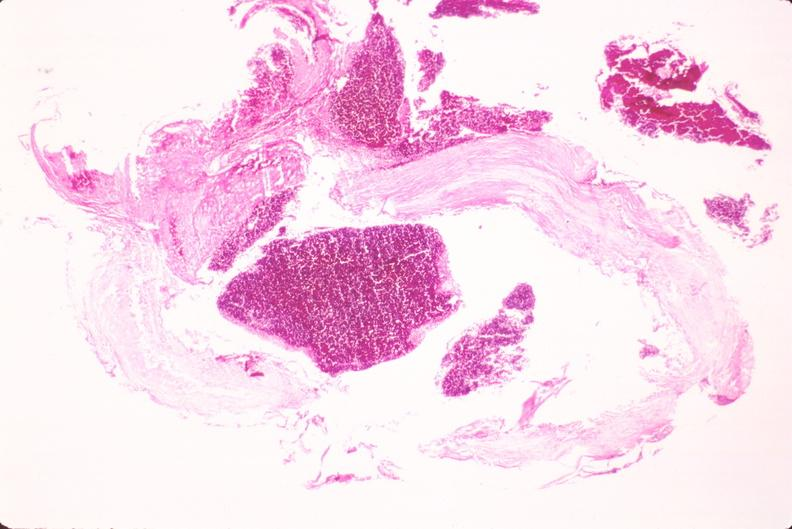s macerated stillborn present?
Answer the question using a single word or phrase. No 